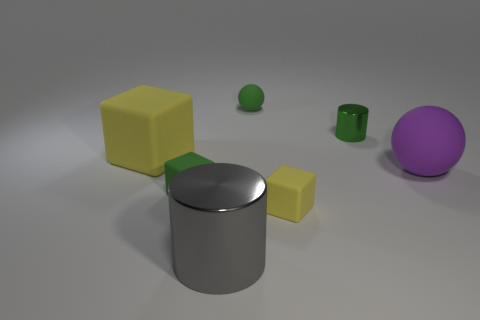There is a large sphere; how many tiny yellow things are to the right of it?
Provide a succinct answer. 0. The large thing in front of the green rubber object in front of the tiny green matte sphere is what color?
Give a very brief answer. Gray. How many other things are the same material as the tiny yellow object?
Provide a short and direct response. 4. Are there the same number of gray shiny cylinders on the right side of the tiny rubber ball and yellow rubber cylinders?
Make the answer very short. Yes. The cylinder that is in front of the large matte object right of the tiny green rubber object right of the big gray metallic object is made of what material?
Your response must be concise. Metal. The rubber sphere that is behind the big cube is what color?
Give a very brief answer. Green. Is there anything else that has the same shape as the tiny green shiny object?
Your response must be concise. Yes. There is a block to the right of the green matte object behind the big purple rubber thing; how big is it?
Your response must be concise. Small. Are there an equal number of large gray metallic cylinders on the left side of the green cylinder and big shiny things that are in front of the large purple rubber ball?
Keep it short and to the point. Yes. There is a big sphere that is made of the same material as the big cube; what is its color?
Offer a terse response. Purple. 